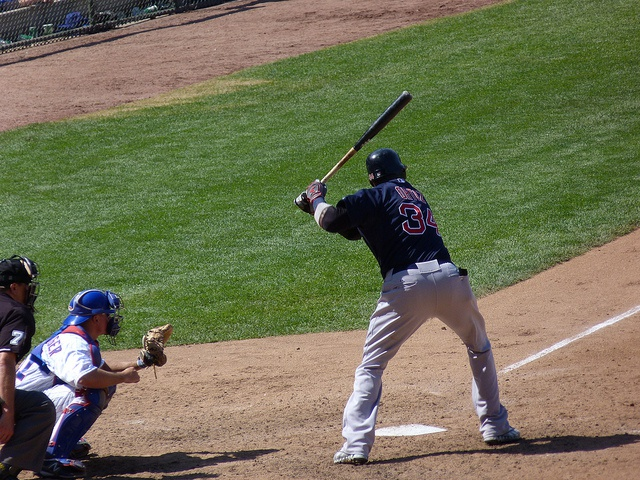Describe the objects in this image and their specific colors. I can see people in blue, black, gray, lavender, and darkgray tones, people in blue, black, white, maroon, and darkgray tones, people in blue, black, maroon, gray, and navy tones, baseball bat in blue, black, darkgreen, gray, and darkgray tones, and baseball glove in blue, black, maroon, and gray tones in this image. 